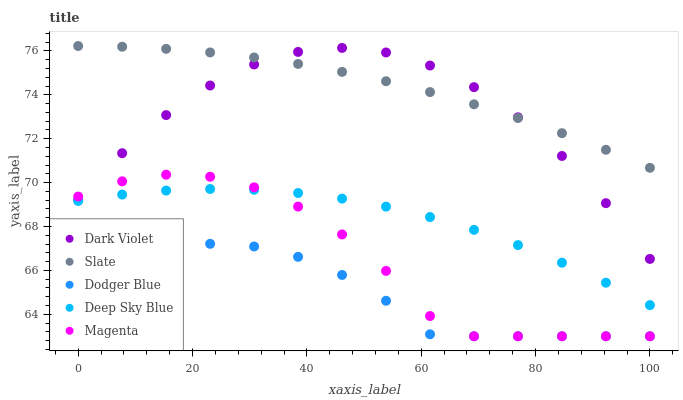Does Dodger Blue have the minimum area under the curve?
Answer yes or no. Yes. Does Slate have the maximum area under the curve?
Answer yes or no. Yes. Does Slate have the minimum area under the curve?
Answer yes or no. No. Does Dodger Blue have the maximum area under the curve?
Answer yes or no. No. Is Slate the smoothest?
Answer yes or no. Yes. Is Magenta the roughest?
Answer yes or no. Yes. Is Dodger Blue the smoothest?
Answer yes or no. No. Is Dodger Blue the roughest?
Answer yes or no. No. Does Magenta have the lowest value?
Answer yes or no. Yes. Does Slate have the lowest value?
Answer yes or no. No. Does Slate have the highest value?
Answer yes or no. Yes. Does Dodger Blue have the highest value?
Answer yes or no. No. Is Deep Sky Blue less than Dark Violet?
Answer yes or no. Yes. Is Deep Sky Blue greater than Dodger Blue?
Answer yes or no. Yes. Does Deep Sky Blue intersect Magenta?
Answer yes or no. Yes. Is Deep Sky Blue less than Magenta?
Answer yes or no. No. Is Deep Sky Blue greater than Magenta?
Answer yes or no. No. Does Deep Sky Blue intersect Dark Violet?
Answer yes or no. No. 